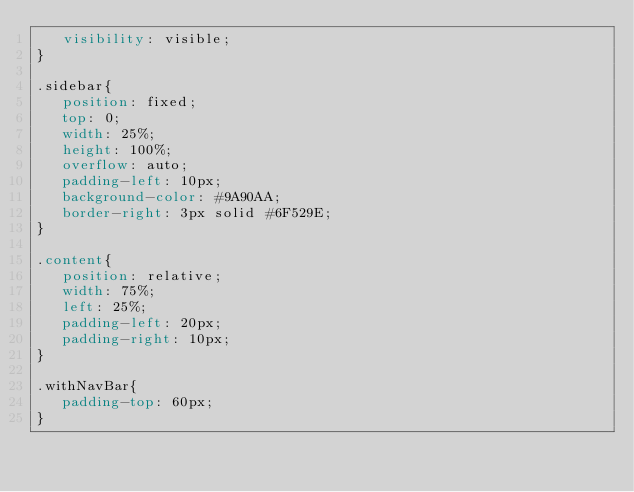<code> <loc_0><loc_0><loc_500><loc_500><_CSS_>   visibility: visible;
}

.sidebar{
   position: fixed;
   top: 0;
   width: 25%;
   height: 100%;
   overflow: auto;
   padding-left: 10px;
   background-color: #9A90AA;
   border-right: 3px solid #6F529E;
}

.content{
   position: relative;
   width: 75%;
   left: 25%;
   padding-left: 20px;
   padding-right: 10px;
}

.withNavBar{
   padding-top: 60px;
}
</code> 